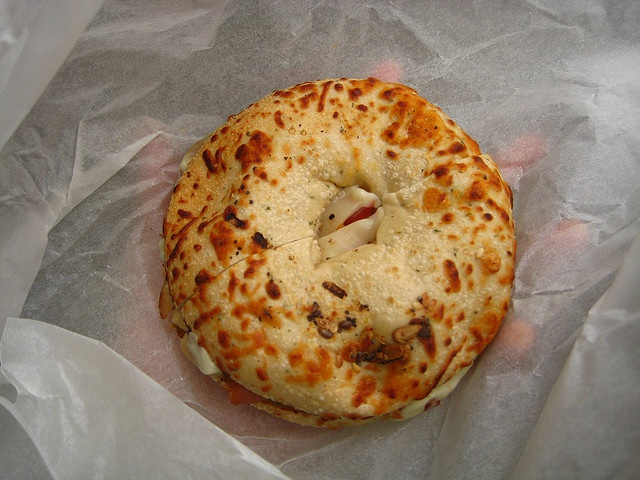Describe the objects in this image and their specific colors. I can see sandwich in darkgray, olive, tan, and maroon tones and people in darkgray and gray tones in this image. 